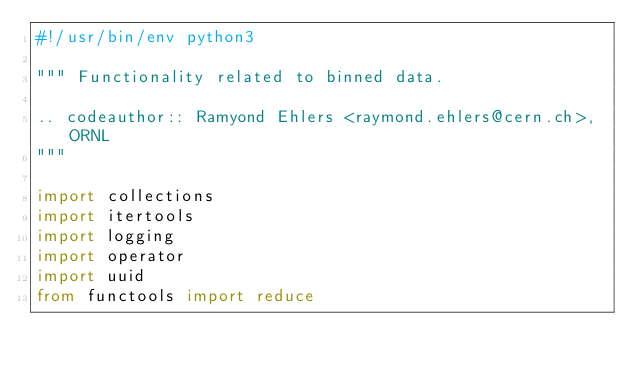Convert code to text. <code><loc_0><loc_0><loc_500><loc_500><_Python_>#!/usr/bin/env python3

""" Functionality related to binned data.

.. codeauthor:: Ramyond Ehlers <raymond.ehlers@cern.ch>, ORNL
"""

import collections
import itertools
import logging
import operator
import uuid
from functools import reduce</code> 